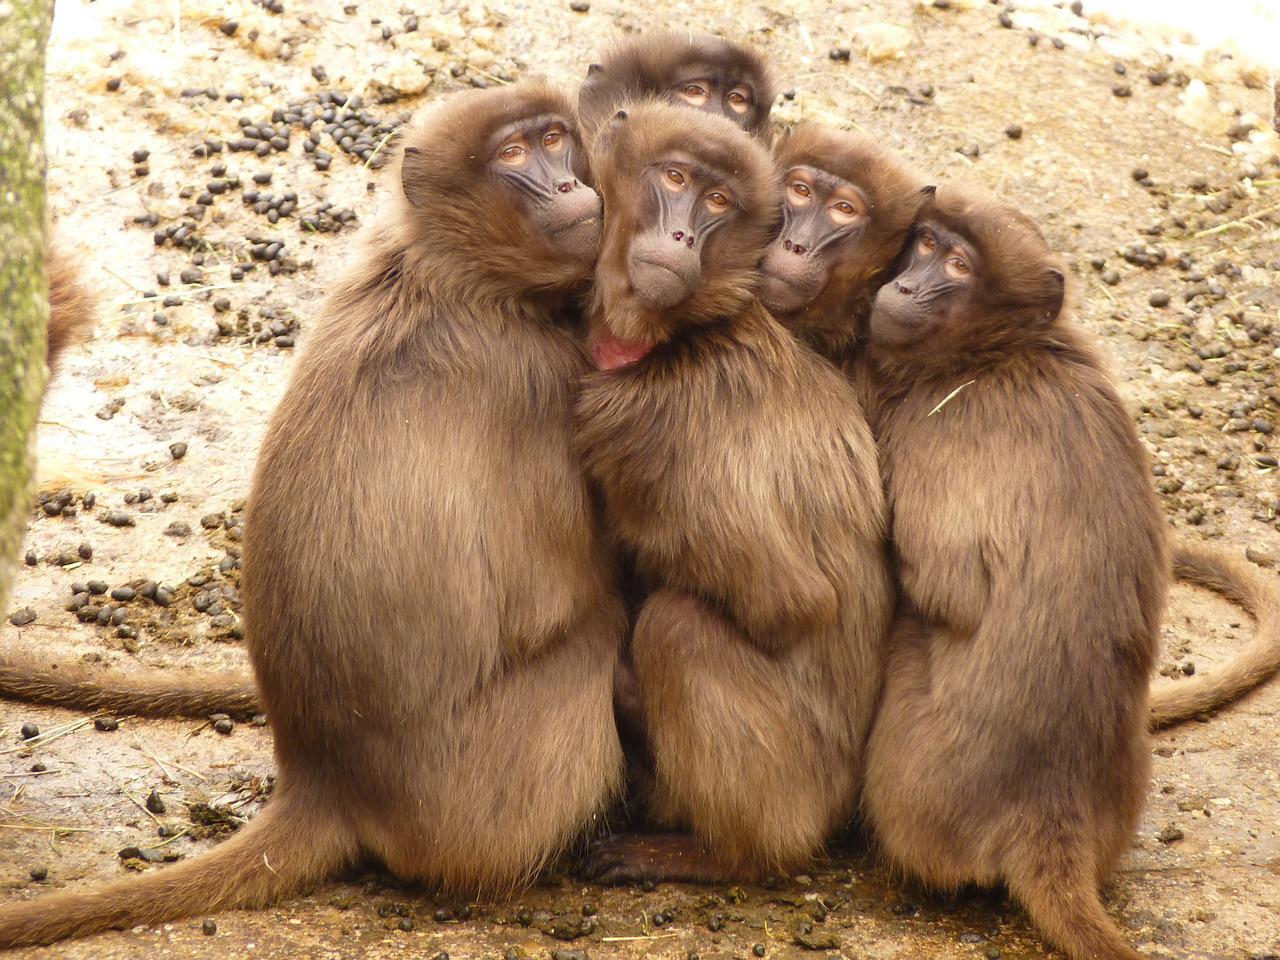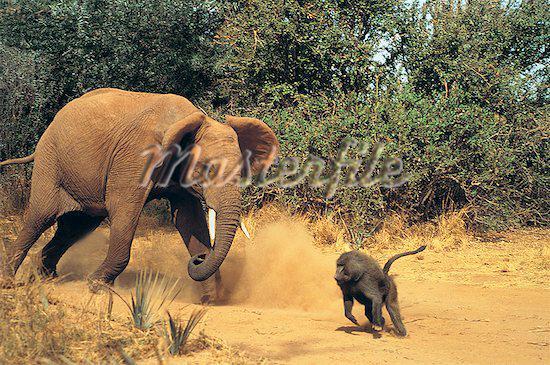The first image is the image on the left, the second image is the image on the right. Considering the images on both sides, is "The right image has a monkey interacting with a warthog." valid? Answer yes or no. No. The first image is the image on the left, the second image is the image on the right. Given the left and right images, does the statement "At least one photo contains a monkey on top of a warthog." hold true? Answer yes or no. No. 